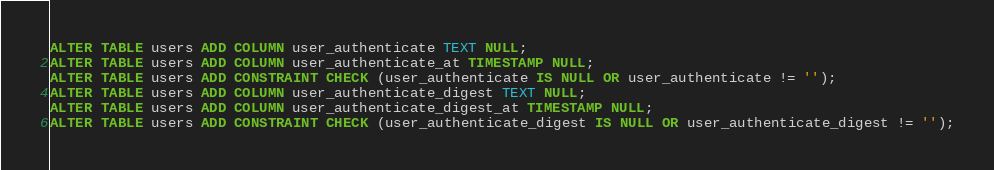<code> <loc_0><loc_0><loc_500><loc_500><_SQL_>ALTER TABLE users ADD COLUMN user_authenticate TEXT NULL;
ALTER TABLE users ADD COLUMN user_authenticate_at TIMESTAMP NULL;
ALTER TABLE users ADD CONSTRAINT CHECK (user_authenticate IS NULL OR user_authenticate != '');
ALTER TABLE users ADD COLUMN user_authenticate_digest TEXT NULL;
ALTER TABLE users ADD COLUMN user_authenticate_digest_at TIMESTAMP NULL;
ALTER TABLE users ADD CONSTRAINT CHECK (user_authenticate_digest IS NULL OR user_authenticate_digest != '');
</code> 